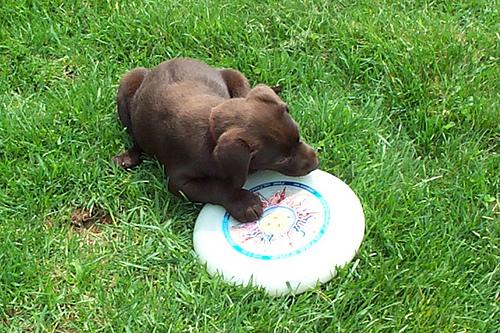What animal is it?
Be succinct. Dog. What breed of dog is this?
Write a very short answer. Lab. What color is the sun face on the Frisbee?
Be succinct. Yellow. Who is laying on the ground?
Short answer required. Dog. 